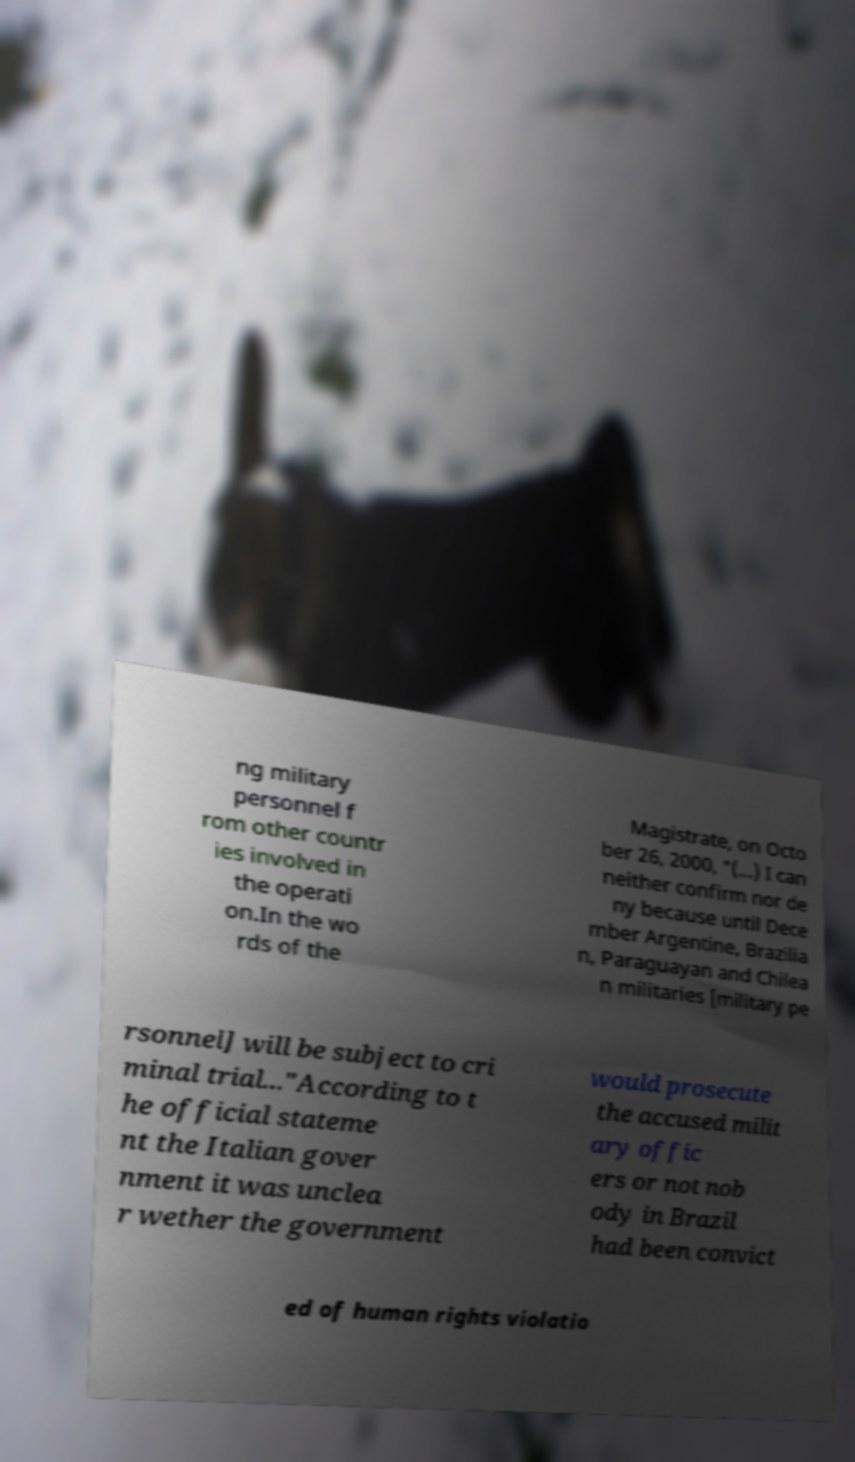There's text embedded in this image that I need extracted. Can you transcribe it verbatim? ng military personnel f rom other countr ies involved in the operati on.In the wo rds of the Magistrate, on Octo ber 26, 2000, "(...) I can neither confirm nor de ny because until Dece mber Argentine, Brazilia n, Paraguayan and Chilea n militaries [military pe rsonnel] will be subject to cri minal trial..."According to t he official stateme nt the Italian gover nment it was unclea r wether the government would prosecute the accused milit ary offic ers or not nob ody in Brazil had been convict ed of human rights violatio 